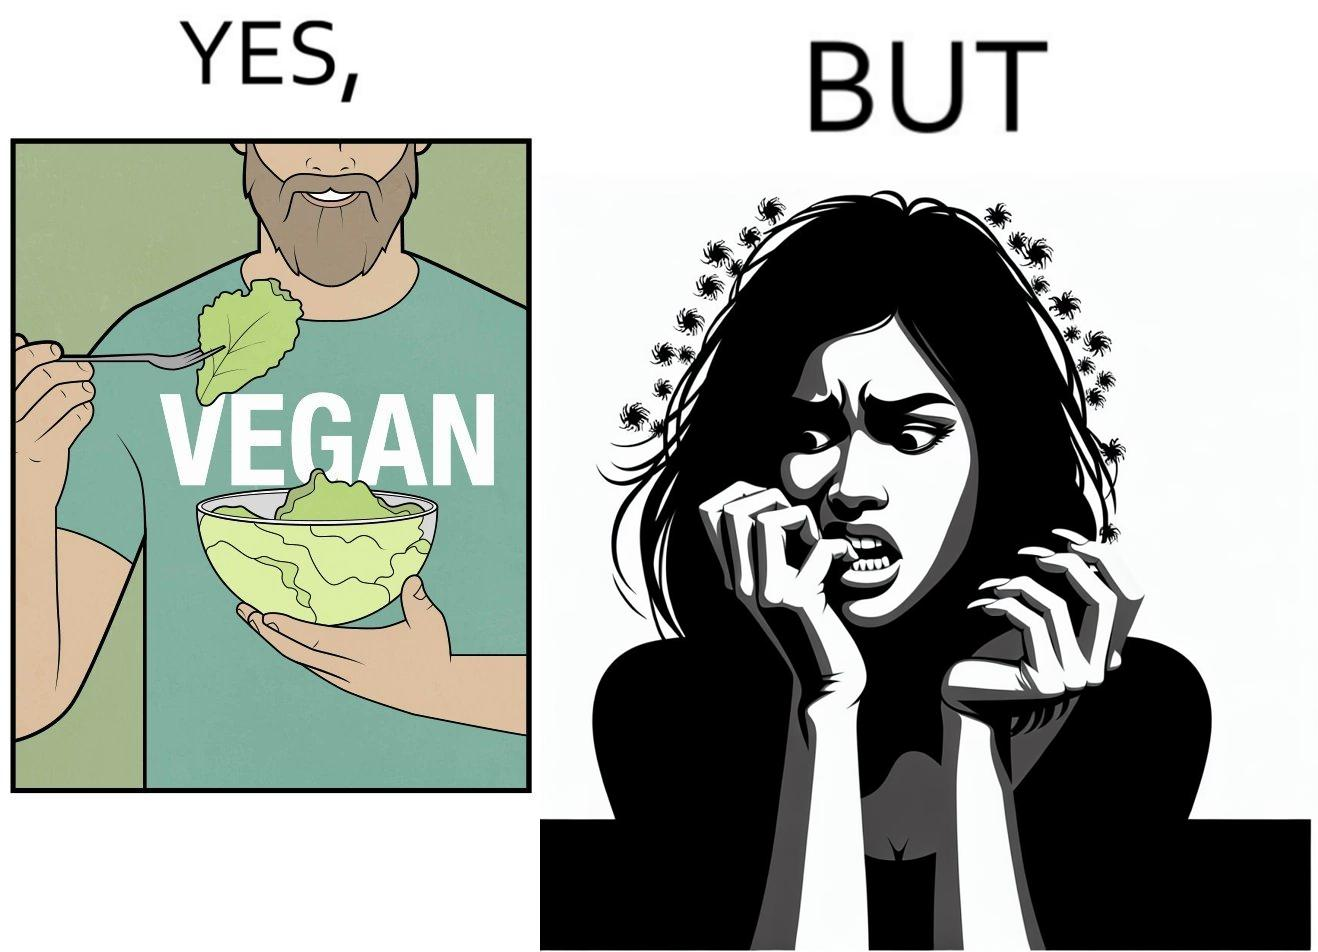Provide a description of this image. The image is funny because while the man claims to be vegan, he is biting skin off his own hand. 